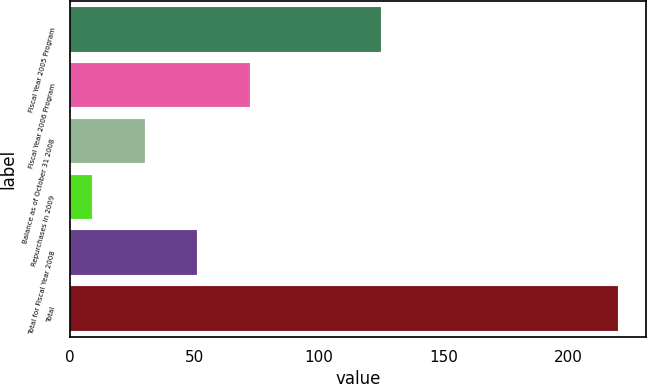<chart> <loc_0><loc_0><loc_500><loc_500><bar_chart><fcel>Fiscal Year 2005 Program<fcel>Fiscal Year 2006 Program<fcel>Balance as of October 31 2008<fcel>Repurchases in 2009<fcel>Total for Fiscal Year 2008<fcel>Total<nl><fcel>125<fcel>72.3<fcel>30.1<fcel>9<fcel>51.2<fcel>220<nl></chart> 